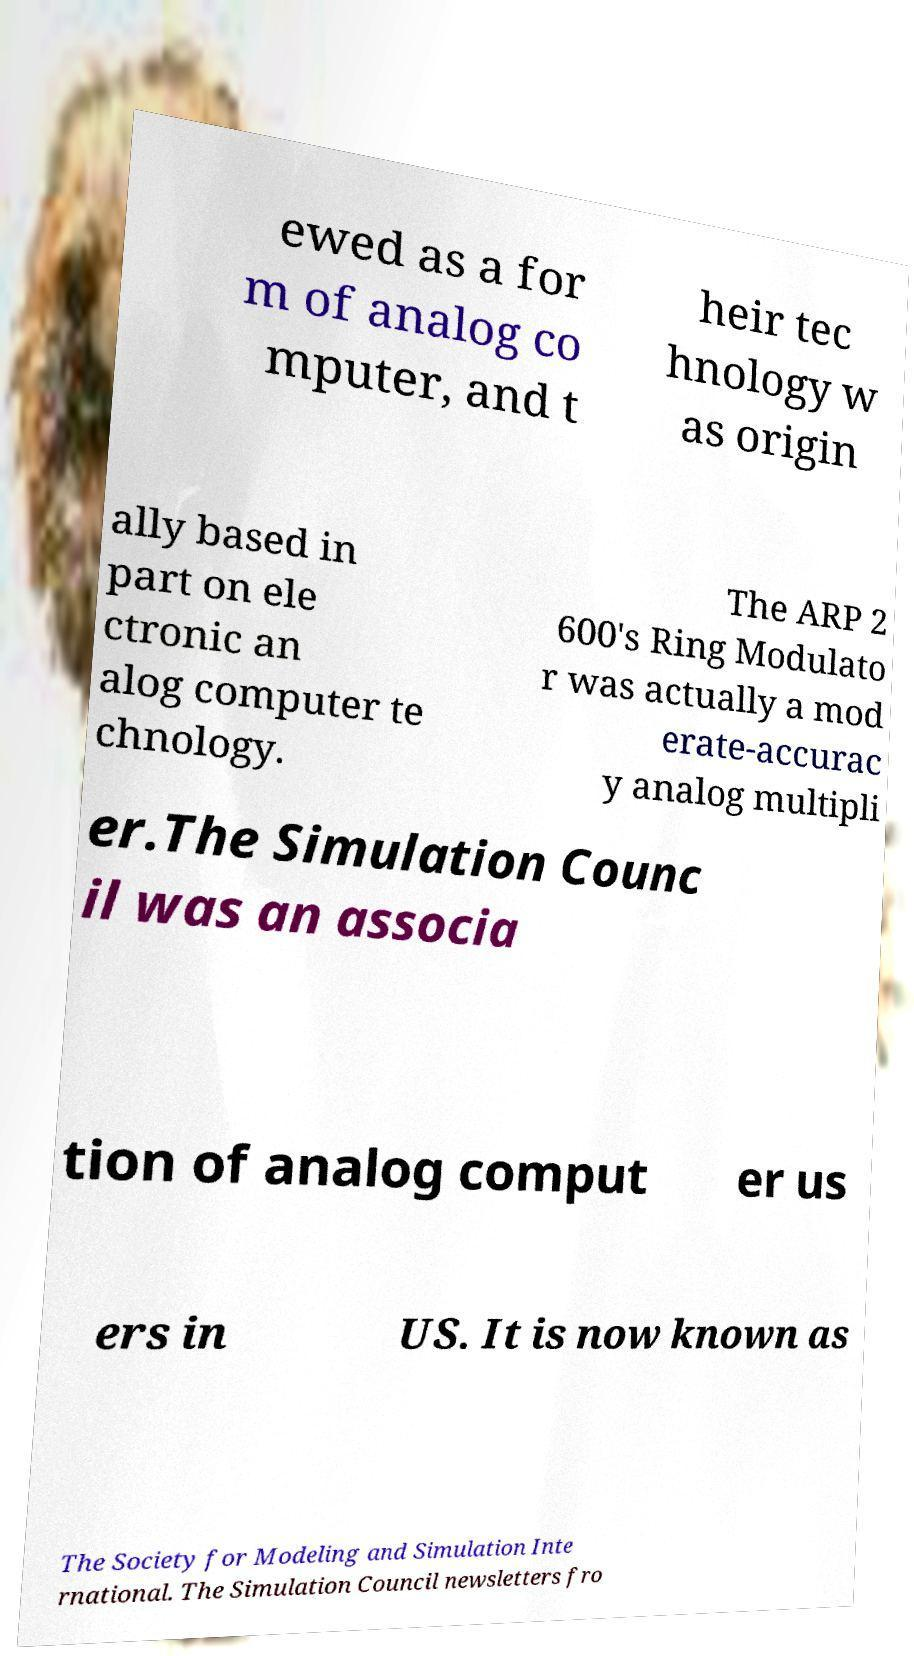For documentation purposes, I need the text within this image transcribed. Could you provide that? ewed as a for m of analog co mputer, and t heir tec hnology w as origin ally based in part on ele ctronic an alog computer te chnology. The ARP 2 600's Ring Modulato r was actually a mod erate-accurac y analog multipli er.The Simulation Counc il was an associa tion of analog comput er us ers in US. It is now known as The Society for Modeling and Simulation Inte rnational. The Simulation Council newsletters fro 